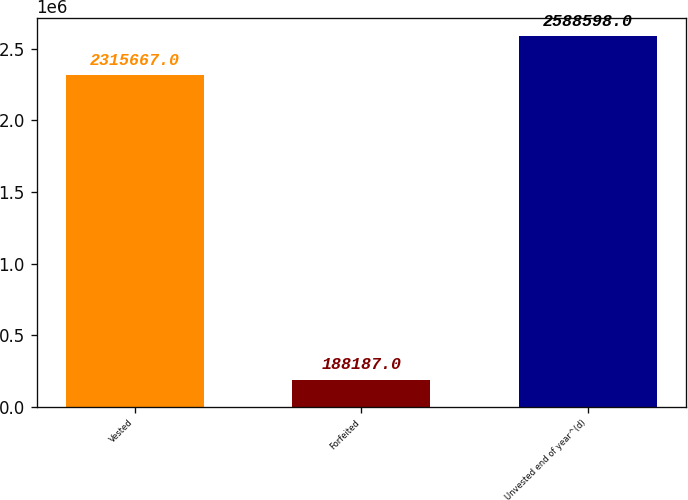Convert chart. <chart><loc_0><loc_0><loc_500><loc_500><bar_chart><fcel>Vested<fcel>Forfeited<fcel>Unvested end of year^(d)<nl><fcel>2.31567e+06<fcel>188187<fcel>2.5886e+06<nl></chart> 